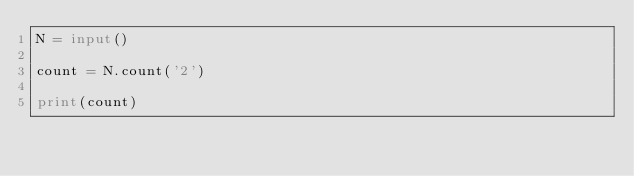Convert code to text. <code><loc_0><loc_0><loc_500><loc_500><_Python_>N = input()

count = N.count('2')

print(count)</code> 